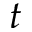Convert formula to latex. <formula><loc_0><loc_0><loc_500><loc_500>t</formula> 